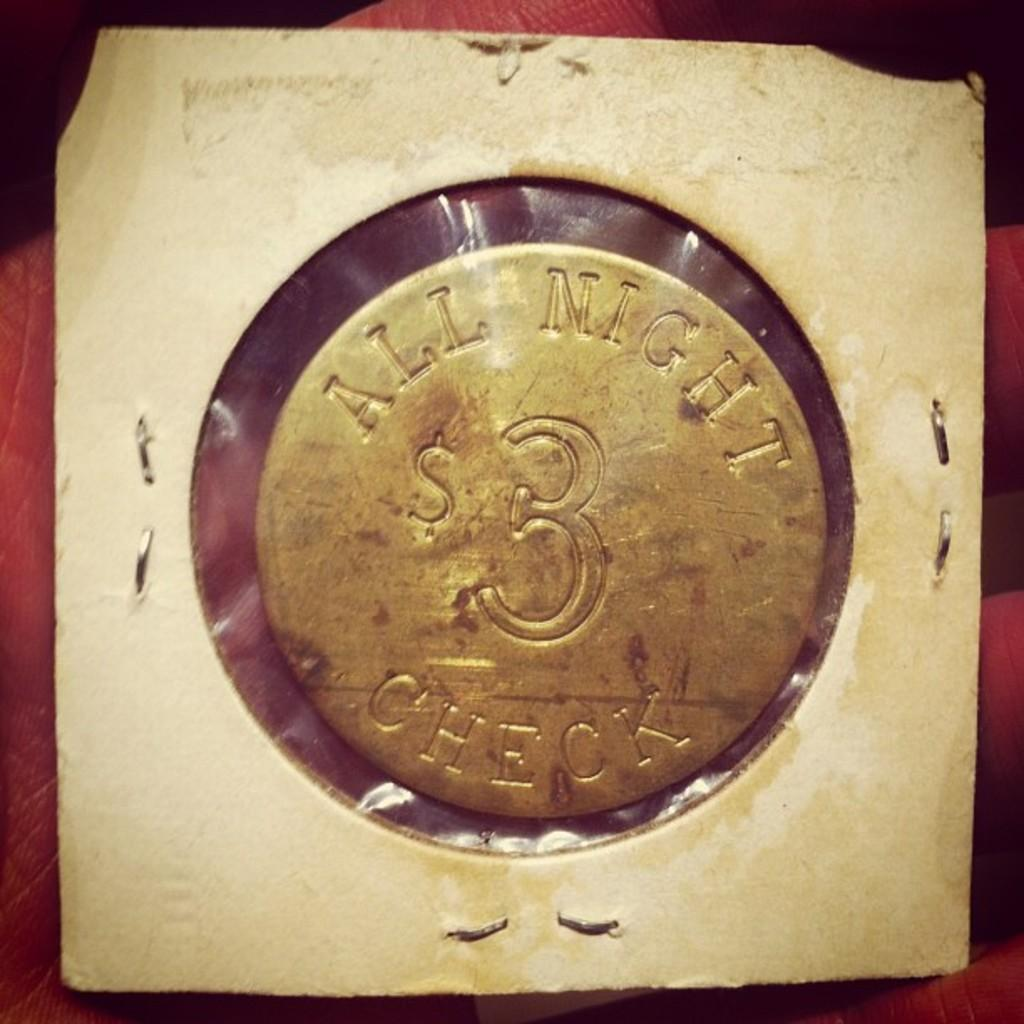<image>
Summarize the visual content of the image. A three dollar coin token is inscribed with the phrase All Night Check. 